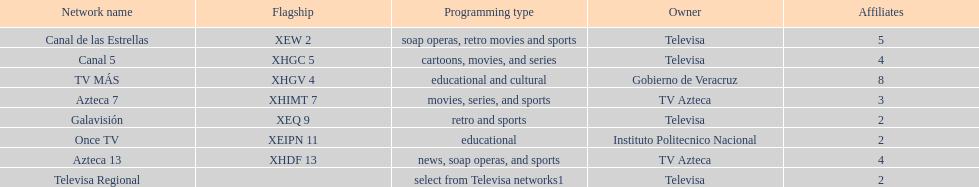Name each of tv azteca's network names. Azteca 7, Azteca 13. Write the full table. {'header': ['Network name', 'Flagship', 'Programming type', 'Owner', 'Affiliates'], 'rows': [['Canal de las Estrellas', 'XEW 2', 'soap operas, retro movies and sports', 'Televisa', '5'], ['Canal 5', 'XHGC 5', 'cartoons, movies, and series', 'Televisa', '4'], ['TV MÁS', 'XHGV 4', 'educational and cultural', 'Gobierno de Veracruz', '8'], ['Azteca 7', 'XHIMT 7', 'movies, series, and sports', 'TV Azteca', '3'], ['Galavisión', 'XEQ 9', 'retro and sports', 'Televisa', '2'], ['Once TV', 'XEIPN 11', 'educational', 'Instituto Politecnico Nacional', '2'], ['Azteca 13', 'XHDF 13', 'news, soap operas, and sports', 'TV Azteca', '4'], ['Televisa Regional', '', 'select from Televisa networks1', 'Televisa', '2']]} 